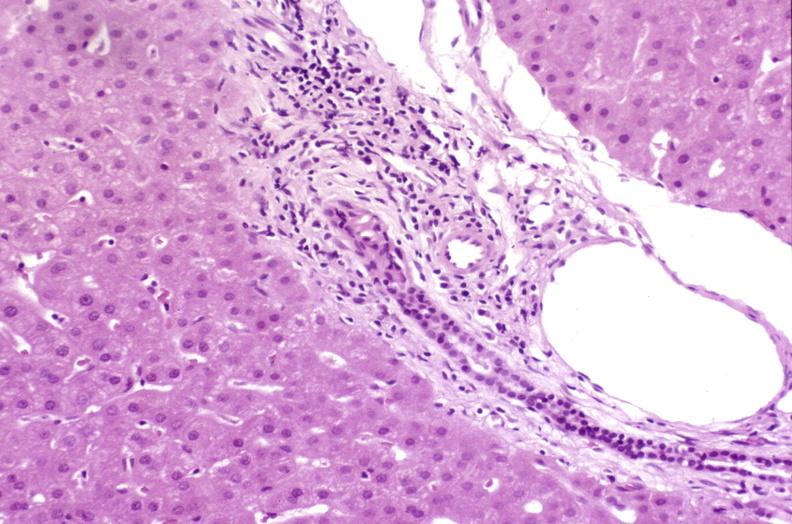what is present?
Answer the question using a single word or phrase. Hepatobiliary 